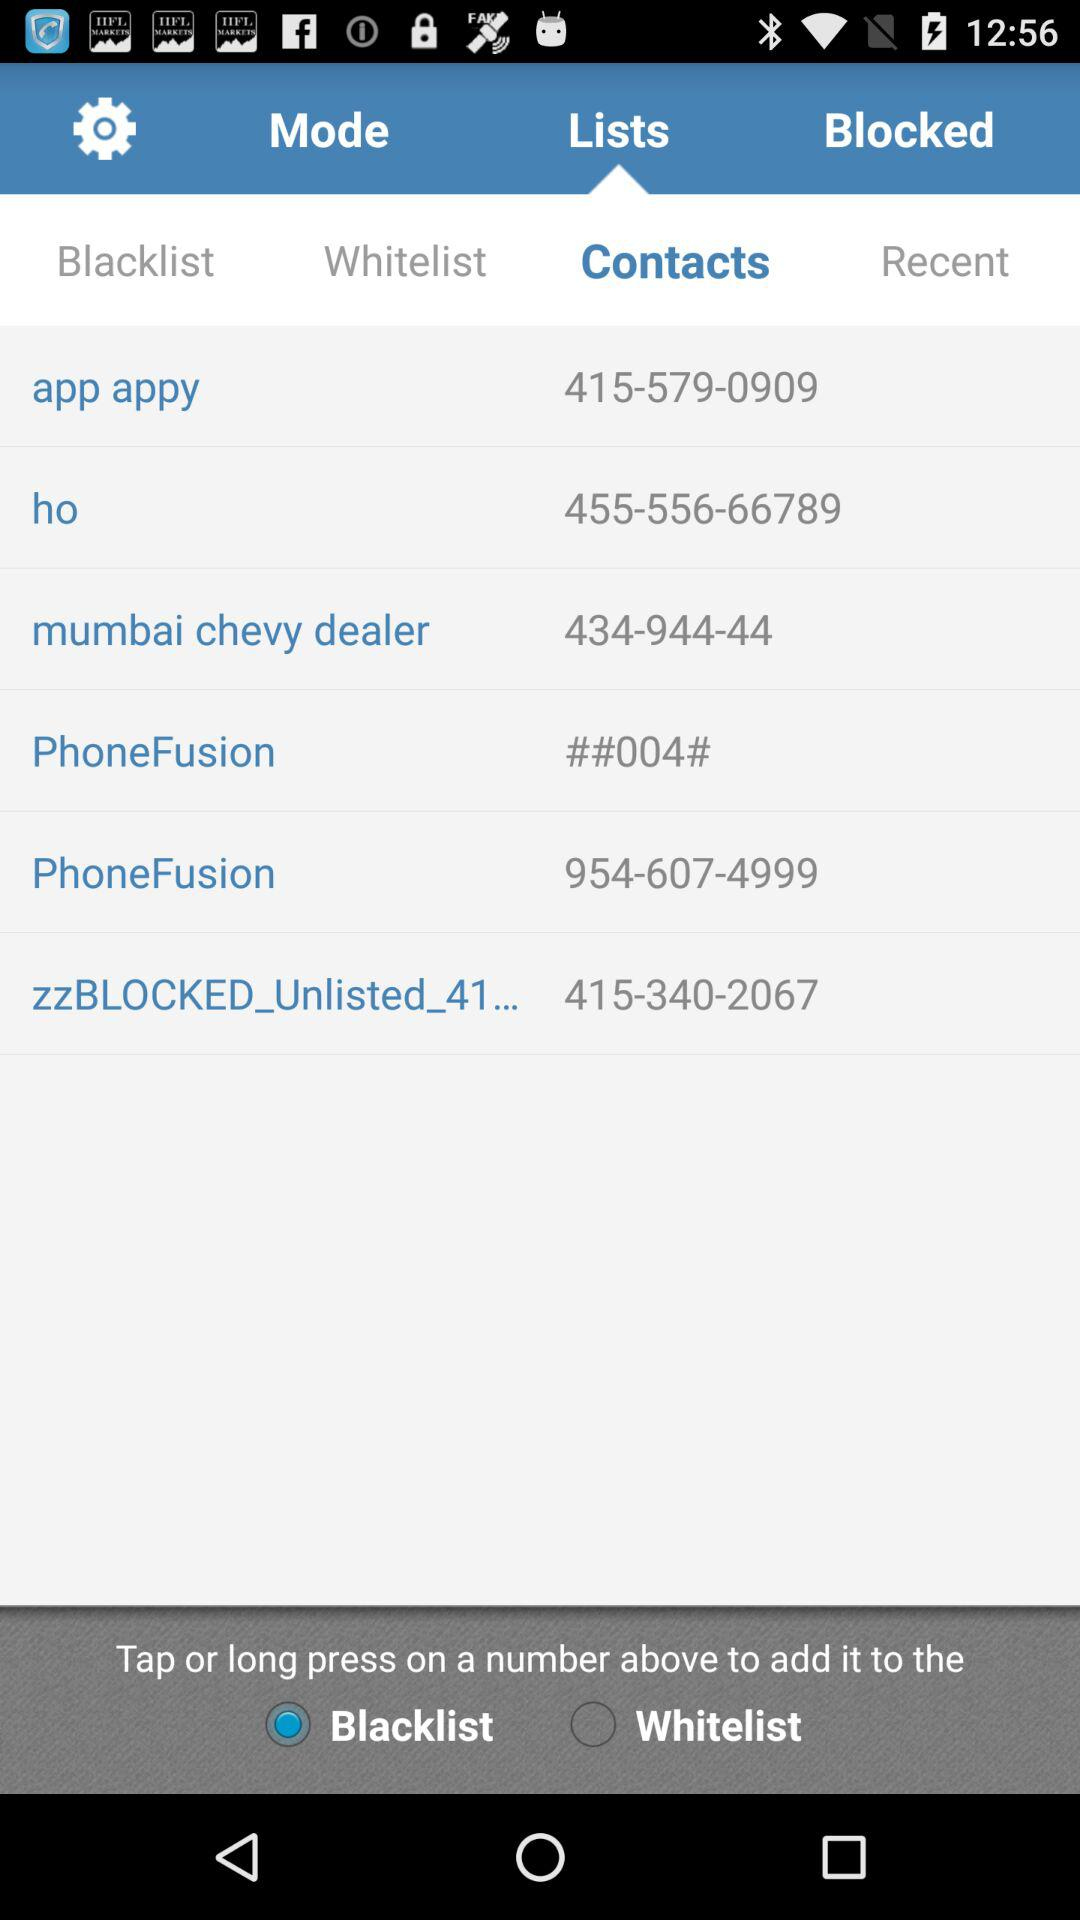What is the contact number of "PhoneFusion"? The contact number is 954-607-4999. 